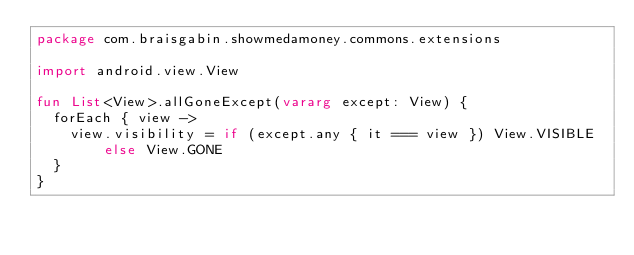Convert code to text. <code><loc_0><loc_0><loc_500><loc_500><_Kotlin_>package com.braisgabin.showmedamoney.commons.extensions

import android.view.View

fun List<View>.allGoneExcept(vararg except: View) {
  forEach { view ->
    view.visibility = if (except.any { it === view }) View.VISIBLE else View.GONE
  }
}
</code> 